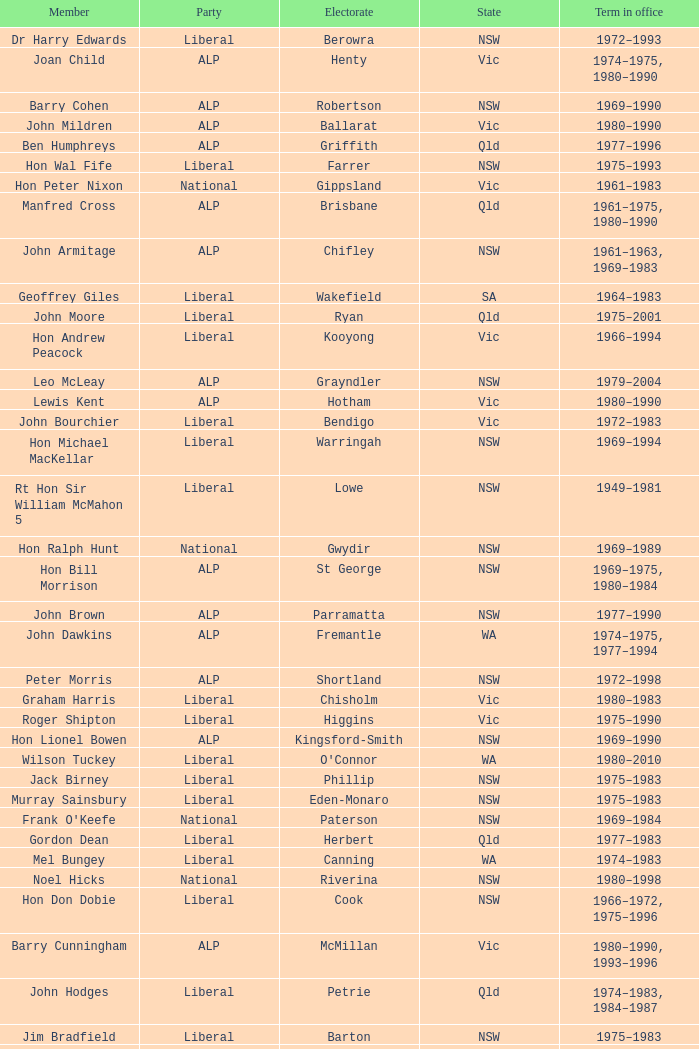What party is Mick Young a member of? ALP. Could you parse the entire table? {'header': ['Member', 'Party', 'Electorate', 'State', 'Term in office'], 'rows': [['Dr Harry Edwards', 'Liberal', 'Berowra', 'NSW', '1972–1993'], ['Joan Child', 'ALP', 'Henty', 'Vic', '1974–1975, 1980–1990'], ['Barry Cohen', 'ALP', 'Robertson', 'NSW', '1969–1990'], ['John Mildren', 'ALP', 'Ballarat', 'Vic', '1980–1990'], ['Ben Humphreys', 'ALP', 'Griffith', 'Qld', '1977–1996'], ['Hon Wal Fife', 'Liberal', 'Farrer', 'NSW', '1975–1993'], ['Hon Peter Nixon', 'National', 'Gippsland', 'Vic', '1961–1983'], ['Manfred Cross', 'ALP', 'Brisbane', 'Qld', '1961–1975, 1980–1990'], ['John Armitage', 'ALP', 'Chifley', 'NSW', '1961–1963, 1969–1983'], ['Geoffrey Giles', 'Liberal', 'Wakefield', 'SA', '1964–1983'], ['John Moore', 'Liberal', 'Ryan', 'Qld', '1975–2001'], ['Hon Andrew Peacock', 'Liberal', 'Kooyong', 'Vic', '1966–1994'], ['Leo McLeay', 'ALP', 'Grayndler', 'NSW', '1979–2004'], ['Lewis Kent', 'ALP', 'Hotham', 'Vic', '1980–1990'], ['John Bourchier', 'Liberal', 'Bendigo', 'Vic', '1972–1983'], ['Hon Michael MacKellar', 'Liberal', 'Warringah', 'NSW', '1969–1994'], ['Rt Hon Sir William McMahon 5', 'Liberal', 'Lowe', 'NSW', '1949–1981'], ['Hon Ralph Hunt', 'National', 'Gwydir', 'NSW', '1969–1989'], ['Hon Bill Morrison', 'ALP', 'St George', 'NSW', '1969–1975, 1980–1984'], ['John Brown', 'ALP', 'Parramatta', 'NSW', '1977–1990'], ['John Dawkins', 'ALP', 'Fremantle', 'WA', '1974–1975, 1977–1994'], ['Peter Morris', 'ALP', 'Shortland', 'NSW', '1972–1998'], ['Graham Harris', 'Liberal', 'Chisholm', 'Vic', '1980–1983'], ['Roger Shipton', 'Liberal', 'Higgins', 'Vic', '1975–1990'], ['Hon Lionel Bowen', 'ALP', 'Kingsford-Smith', 'NSW', '1969–1990'], ['Wilson Tuckey', 'Liberal', "O'Connor", 'WA', '1980–2010'], ['Jack Birney', 'Liberal', 'Phillip', 'NSW', '1975–1983'], ['Murray Sainsbury', 'Liberal', 'Eden-Monaro', 'NSW', '1975–1983'], ["Frank O'Keefe", 'National', 'Paterson', 'NSW', '1969–1984'], ['Gordon Dean', 'Liberal', 'Herbert', 'Qld', '1977–1983'], ['Mel Bungey', 'Liberal', 'Canning', 'WA', '1974–1983'], ['Noel Hicks', 'National', 'Riverina', 'NSW', '1980–1998'], ['Hon Don Dobie', 'Liberal', 'Cook', 'NSW', '1966–1972, 1975–1996'], ['Barry Cunningham', 'ALP', 'McMillan', 'Vic', '1980–1990, 1993–1996'], ['John Hodges', 'Liberal', 'Petrie', 'Qld', '1974–1983, 1984–1987'], ['Jim Bradfield', 'Liberal', 'Barton', 'NSW', '1975–1983'], ['Hon Dr Doug Everingham', 'ALP', 'Capricornia', 'Qld', '1967–1975, 1977–1984'], ['Bruce Cowan', 'National', 'Lyne', 'NSW', '1980–1993'], ['Hon Kevin Newman', 'Liberal', 'Bass', 'Tas', '1975–1984'], ['Ian Cameron', 'National', 'Maranoa', 'Qld', '1980–1990'], ['Grant Chapman', 'Liberal', 'Kingston', 'SA', '1975–1983'], ['Kim Beazley', 'ALP', 'Swan', 'WA', '1980–2007'], ['Ian Wilson', 'Liberal', 'Sturt', 'SA', '1966–1969, 1972–1993'], ['Rt Hon Malcolm Fraser', 'Liberal', 'Wannon', 'Vic', '1955–1984'], ['Elaine Darling', 'ALP', 'Lilley', 'Qld', '1980–1993'], ['Ken Fry', 'ALP', 'Fraser', 'ACT', '1974–1984'], ['Peter Shack', 'Liberal', 'Tangney', 'WA', '1977–1983, 1984–1993'], ['Michael Duffy', 'ALP', 'Holt', 'Vic', '1980–1996'], ['Hon Jim Killen', 'Liberal', 'Moreton', 'Qld', '1955–1983'], ['Dr Andrew Theophanous', 'ALP', 'Burke', 'Vic', '1980–2001'], ['Steele Hall 2', 'Liberal', 'Boothby', 'SA', '1981–1996'], ['Ralph Willis', 'ALP', 'Gellibrand', 'Vic', '1972–1998'], ['Michael Maher 5', 'ALP', 'Lowe', 'NSW', '1982–1987'], ['Hon Ian Robinson', 'National', 'Cowper', 'NSW', '1963–1981'], ['John Kerin', 'ALP', 'Werriwa', 'NSW', '1972–1975, 1978–1994'], ['Barry Jones', 'ALP', 'Lalor', 'Vic', '1977–1998'], ['Michael Hodgman', 'Liberal', 'Denison', 'Tas', '1975–1987'], ['Stewart West', 'ALP', 'Cunningham', 'NSW', '1977–1993'], ['John Mountford', 'ALP', 'Banks', 'NSW', '1980–1990'], ['Hon Victor Garland 3', 'Liberal', 'Curtin', 'WA', '1969–1981'], ['David Jull', 'Liberal', 'Bowman', 'Qld', '1975–1983, 1984–2007'], ['Ralph Jacobi', 'ALP', 'Hawker', 'SA', '1969–1987'], ['Grant Tambling', 'CLP', 'Northern Territory', 'NT', '1980–1983'], ['Hon Ray Groom', 'Liberal', 'Braddon', 'Tas', '1975–1984'], ['Hon Evan Adermann', 'National', 'Fisher', 'Qld', '1972–1990'], ['Hon Gordon Scholes', 'ALP', 'Corio', 'Vic', '1967–1993'], ['Ross McLean', 'Liberal', 'Perth', 'WA', '1975–1983'], ['Michael Baume', 'Liberal', 'Macarthur', 'NSW', '1975–1983'], ['Hon Tom Uren', 'ALP', 'Reid', 'NSW', '1958–1990'], ['Philip Ruddock', 'Liberal', 'Dundas', 'NSW', '1973–present'], ['Brian Howe', 'ALP', 'Batman', 'Vic', '1977–1996'], ['Hon Charles Jones', 'ALP', 'Newcastle', 'NSW', '1958–1983'], ['Jim Carlton', 'Liberal', 'Mackellar', 'NSW', '1977–1994'], ['Bob Hawke', 'ALP', 'Wills', 'Vic', '1980–1992'], ['Clyde Holding', 'ALP', 'Melbourne Ports', 'Vic', '1977–1998'], ['Stephen Lusher', 'National', 'Hume', 'NSW', '1974–1984'], ['Peter Milton', 'ALP', 'La Trobe', 'Vic', '1980–1990'], ['Rt Hon Doug Anthony', 'National', 'Richmond', 'NSW', '1957–1984'], ['Rt Hon Ian Sinclair', 'National', 'New England', 'NSW', '1963–1998'], ['Hon John Howard', 'Liberal', 'Bennelong', 'NSW', '1974–2007'], ['Rt Hon Phillip Lynch 6', 'Liberal', 'Flinders', 'Vic', '1966–1982'], ['Bruce Lloyd', 'National', 'Murray', 'Vic', '1971–1996'], ['Peter White 1', 'Liberal', 'McPherson', 'Qld', '1981–1990'], ['Bob Brown', 'ALP', 'Hunter', 'NSW', '1980–1998'], ['Peter Coleman 4', 'Liberal', 'Wentworth', 'NSW', '1981–1987'], ['David Charles', 'ALP', 'Isaacs', 'Vic', '1980–1990'], ['Peter Falconer', 'Liberal', 'Casey', 'Vic', '1975–1983'], ['Laurie Wallis', 'ALP', 'Grey', 'SA', '1969–1983'], ['John Scott', 'ALP', 'Hindmarsh', 'SA', '1980–1993'], ['Ros Kelly', 'ALP', 'Canberra', 'ACT', '1980–1995'], ['Clarrie Millar', 'National', 'Wide Bay', 'Qld', '1974–1990'], ['Hon Bob Katter', 'National', 'Kennedy', 'Qld', '1966–1990'], ['Alan Cadman', 'Liberal', 'Mitchell', 'NSW', '1974–2007'], ['Mick Young', 'ALP', 'Port Adelaide', 'SA', '1974–1988'], ['Donald Milner Cameron', 'Liberal', 'Fadden', 'Qld', '1966–1990'], ['Rt Hon Sir Billy Snedden', 'Liberal', 'Bruce', 'Vic', '1955–1983'], ['Alan Jarman', 'Liberal', 'Deakin', 'Vic', '1966–1983'], ['Bruce Goodluck', 'Liberal', 'Franklin', 'Tas', '1975–1993'], ['Hon John McLeay 2', 'Liberal', 'Boothby', 'SA', '1966–1981'], ['Allan Rocher 3', 'Liberal', 'Curtin', 'WA', '1981–1998'], ['Hon Paul Keating', 'ALP', 'Blaxland', 'NSW', '1969–1996'], ['Hon Tony Street', 'Liberal', 'Corangamite', 'Vic', '1966–1984'], ['Dr Neal Blewett', 'ALP', 'Bonython', 'SA', '1977–1994'], ['Hon David Thomson', 'National', 'Leichhardt', 'Qld', '1975–1983'], ['John Spender', 'Liberal', 'North Sydney', 'NSW', '1980–1990'], ['Hon Eric Robinson 1', 'Liberal', 'McPherson', 'Qld', '1972–1990'], ['Ted Innes', 'ALP', 'Melbourne', 'Vic', '1972–1983'], ['Ray Braithwaite', 'National', 'Dawson', 'Qld', '1975–1996'], ['Sandy Mackenzie', 'National', 'Calare', 'NSW', '1975–1983'], ['James Porter', 'Liberal', 'Barker', 'SA', '1975–1990'], ['Hon Les Johnson', 'ALP', 'Hughes', 'NSW', '1955–1966, 1969–1984'], ['John Hyde', 'Liberal', 'Moore', 'WA', '1974–1983'], ['Chris Hurford', 'ALP', 'Adelaide', 'SA', '1969–1988'], ['Tom McVeigh', 'National', 'Darling Downs', 'Qld', '1972–1988'], ['David Connolly', 'Liberal', 'Bradfield', 'NSW', '1974–1996'], ['Peter Reith 6', 'Liberal', 'Flinders', 'Vic', '1982–1983, 1984–2001'], ['Peter Drummond', 'Liberal', 'Forrest', 'WA', '1972–1987'], ['Dr Dick Klugman', 'ALP', 'Prospect', 'NSW', '1969–1990'], ['Hon Robert Ellicott 4', 'Liberal', 'Wentworth', 'NSW', '1974–1981'], ['Ewen Cameron', 'Liberal', 'Indi', 'Vic', '1977–1993'], ['Graeme Campbell', 'ALP', 'Kalgoorlie', 'WA', '1980–1998'], ['Neil Brown', 'Liberal', 'Diamond Valley', 'Vic', '1969–1972, 1975–1991'], ['Hon Dr Moss Cass', 'ALP', 'Maribyrnong', 'Vic', '1969–1983'], ['Dr Harry Jenkins', 'ALP', 'Scullin', 'Vic', '1969–1985'], ['Leslie McMahon', 'ALP', 'Sydney', 'NSW', '1975–1983'], ['Hon Bill Hayden', 'ALP', 'Oxley', 'Qld', '1961–1988'], ['Hon Ian Macphee', 'Liberal', 'Balaclava', 'Vic', '1974–1990'], ['Peter Fisher', 'National', 'Mallee', 'Vic', '1972–1993'], ['Ross Free', 'ALP', 'Macquarie', 'NSW', '1980–1996'], ['Max Burr', 'Liberal', 'Wilmot', 'Tas', '1975–1993'], ['Hon Ian Viner', 'Liberal', 'Stirling', 'WA', '1972–1983']]} 